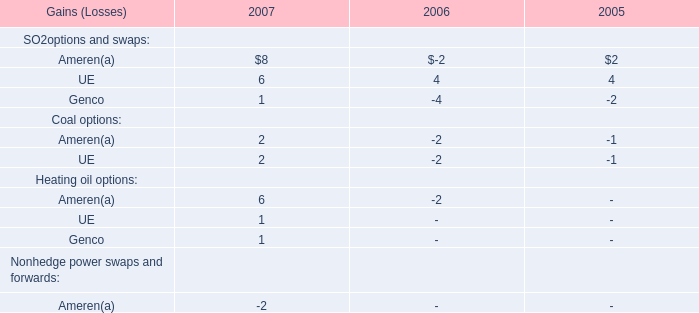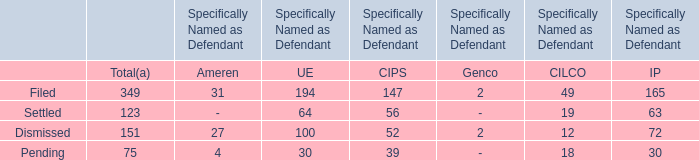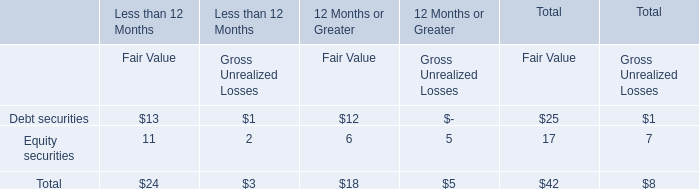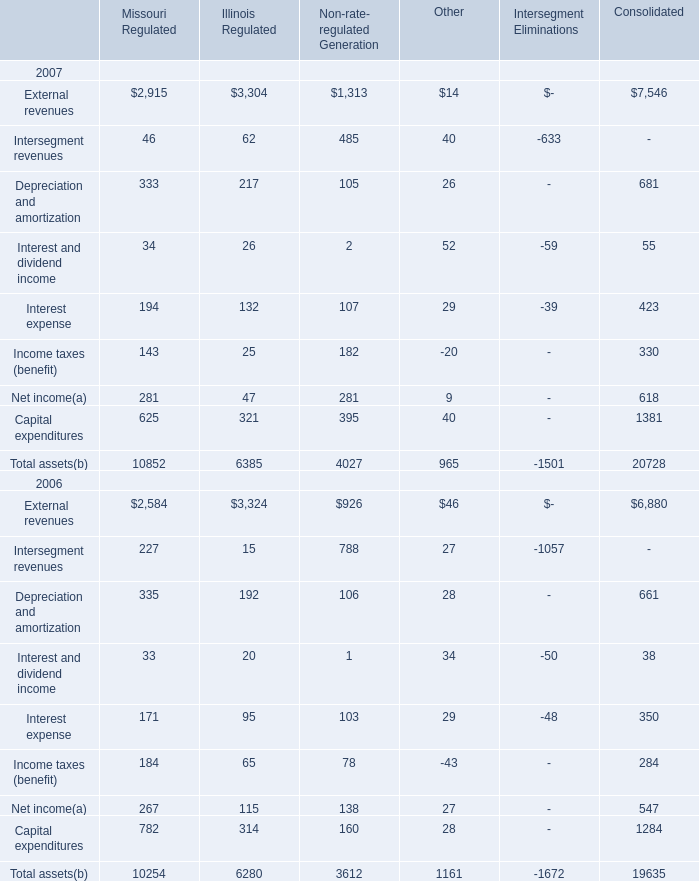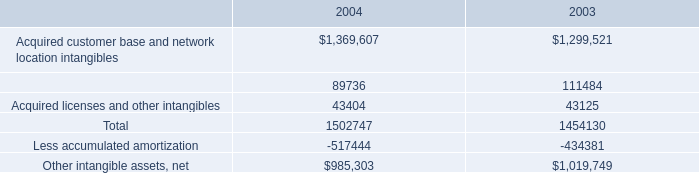what is the percentage change in amortization expense from from 2007 to 2008? 
Computations: ((95.9 - 92.0) / 92.0)
Answer: 0.04239. 